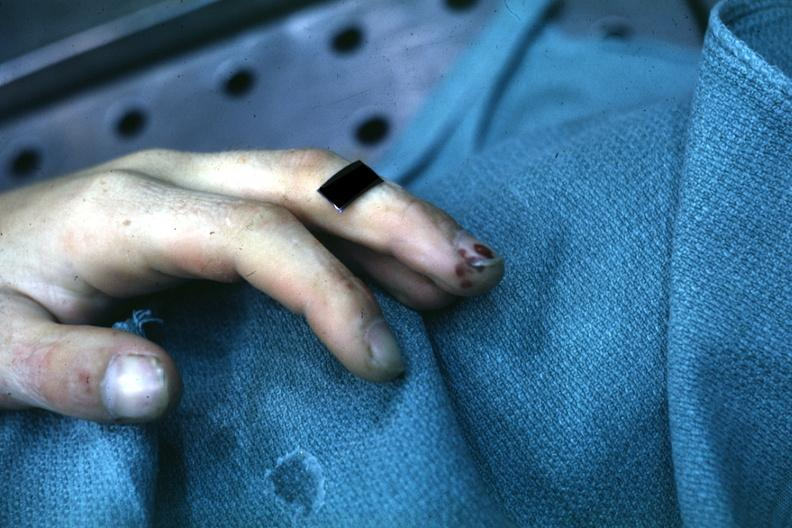re extremities present?
Answer the question using a single word or phrase. Yes 